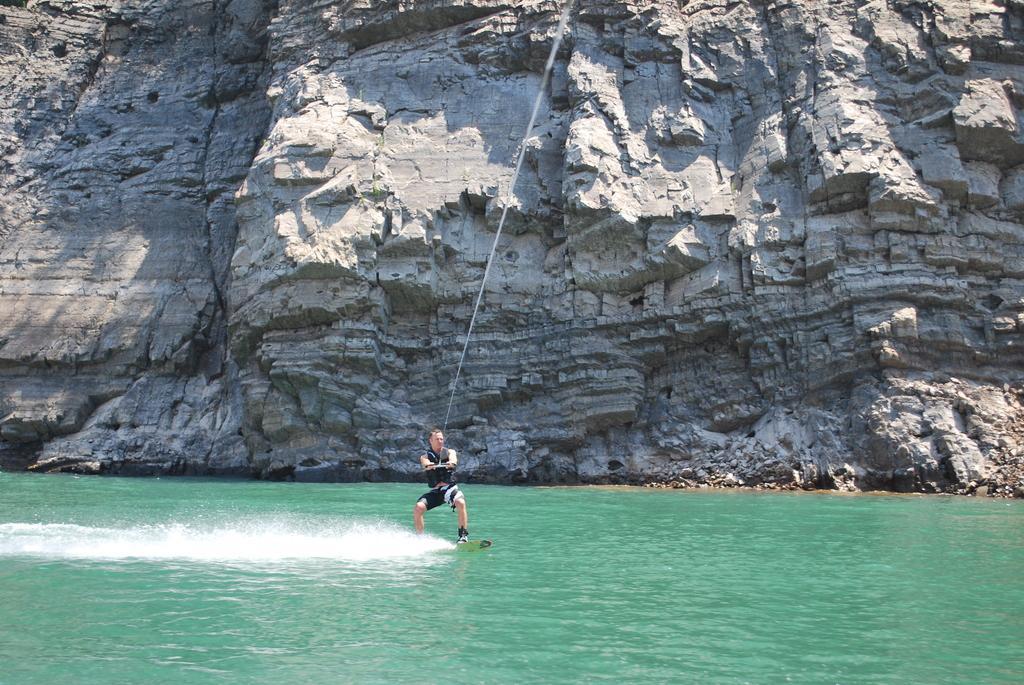Can you describe this image briefly? In this image there is a person surfing with a surf board on the water by holding a rope, and in the background there is a hill. 